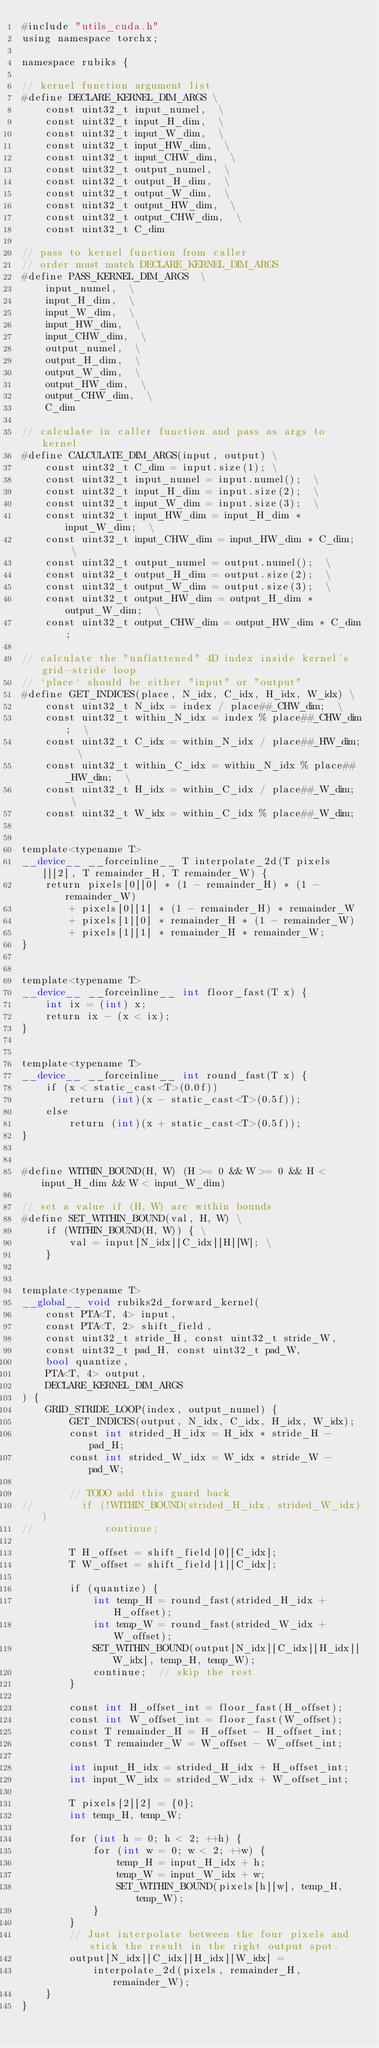<code> <loc_0><loc_0><loc_500><loc_500><_Cuda_>#include "utils_cuda.h"
using namespace torchx;

namespace rubiks {

// kernel function argument list
#define DECLARE_KERNEL_DIM_ARGS \
    const uint32_t input_numel,  \
    const uint32_t input_H_dim,  \
    const uint32_t input_W_dim,  \
    const uint32_t input_HW_dim,  \
    const uint32_t input_CHW_dim,  \
    const uint32_t output_numel,  \
    const uint32_t output_H_dim,  \
    const uint32_t output_W_dim,  \
    const uint32_t output_HW_dim,  \
    const uint32_t output_CHW_dim,  \
    const uint32_t C_dim
    
// pass to kernel function from caller
// order must match DECLARE_KERNEL_DIM_ARGS
#define PASS_KERNEL_DIM_ARGS  \
    input_numel,  \
    input_H_dim,  \
    input_W_dim,  \
    input_HW_dim,  \
    input_CHW_dim,  \
    output_numel,  \
    output_H_dim,  \
    output_W_dim,  \
    output_HW_dim,  \
    output_CHW_dim,  \
    C_dim

// calculate in caller function and pass as args to kernel
#define CALCULATE_DIM_ARGS(input, output) \
    const uint32_t C_dim = input.size(1); \
    const uint32_t input_numel = input.numel();  \
    const uint32_t input_H_dim = input.size(2);  \
    const uint32_t input_W_dim = input.size(3);  \
    const uint32_t input_HW_dim = input_H_dim * input_W_dim;  \
    const uint32_t input_CHW_dim = input_HW_dim * C_dim;  \
    const uint32_t output_numel = output.numel();  \
    const uint32_t output_H_dim = output.size(2);  \
    const uint32_t output_W_dim = output.size(3);  \
    const uint32_t output_HW_dim = output_H_dim * output_W_dim;  \
    const uint32_t output_CHW_dim = output_HW_dim * C_dim;

// calculate the "unflattened" 4D index inside kernel's grid-stride loop
// `place` should be either "input" or "output"
#define GET_INDICES(place, N_idx, C_idx, H_idx, W_idx) \
    const uint32_t N_idx = index / place##_CHW_dim;  \
    const uint32_t within_N_idx = index % place##_CHW_dim;  \
    const uint32_t C_idx = within_N_idx / place##_HW_dim;  \
    const uint32_t within_C_idx = within_N_idx % place##_HW_dim;  \
    const uint32_t H_idx = within_C_idx / place##_W_dim;  \
    const uint32_t W_idx = within_C_idx % place##_W_dim;


template<typename T>
__device__ __forceinline__ T interpolate_2d(T pixels[][2], T remainder_H, T remainder_W) {
    return pixels[0][0] * (1 - remainder_H) * (1 - remainder_W)
        + pixels[0][1] * (1 - remainder_H) * remainder_W
        + pixels[1][0] * remainder_H * (1 - remainder_W)
        + pixels[1][1] * remainder_H * remainder_W;
}


template<typename T>
__device__ __forceinline__ int floor_fast(T x) {
    int ix = (int) x;
    return ix - (x < ix);
}


template<typename T>
__device__ __forceinline__ int round_fast(T x) {
    if (x < static_cast<T>(0.0f))
        return (int)(x - static_cast<T>(0.5f));
    else
        return (int)(x + static_cast<T>(0.5f));
}


#define WITHIN_BOUND(H, W) (H >= 0 && W >= 0 && H < input_H_dim && W < input_W_dim)

// set a value if (H, W) are within bounds
#define SET_WITHIN_BOUND(val, H, W) \
    if (WITHIN_BOUND(H, W)) { \
        val = input[N_idx][C_idx][H][W]; \
    }


template<typename T>
__global__ void rubiks2d_forward_kernel(
    const PTA<T, 4> input,
    const PTA<T, 2> shift_field,
    const uint32_t stride_H, const uint32_t stride_W,
    const uint32_t pad_H, const uint32_t pad_W,
    bool quantize,
    PTA<T, 4> output,
    DECLARE_KERNEL_DIM_ARGS
) {
    GRID_STRIDE_LOOP(index, output_numel) {
        GET_INDICES(output, N_idx, C_idx, H_idx, W_idx);
        const int strided_H_idx = H_idx * stride_H - pad_H;
        const int strided_W_idx = W_idx * stride_W - pad_W;

        // TODO add this guard back
//        if (!WITHIN_BOUND(strided_H_idx, strided_W_idx))
//            continue;

        T H_offset = shift_field[0][C_idx];
        T W_offset = shift_field[1][C_idx];

        if (quantize) {
            int temp_H = round_fast(strided_H_idx + H_offset);
            int temp_W = round_fast(strided_W_idx + W_offset);
            SET_WITHIN_BOUND(output[N_idx][C_idx][H_idx][W_idx], temp_H, temp_W);
            continue;  // skip the rest
        }

        const int H_offset_int = floor_fast(H_offset);
        const int W_offset_int = floor_fast(W_offset);
        const T remainder_H = H_offset - H_offset_int;
        const T remainder_W = W_offset - W_offset_int;

        int input_H_idx = strided_H_idx + H_offset_int;
        int input_W_idx = strided_W_idx + W_offset_int;

        T pixels[2][2] = {0};
        int temp_H, temp_W;

        for (int h = 0; h < 2; ++h) {
            for (int w = 0; w < 2; ++w) {
                temp_H = input_H_idx + h;
                temp_W = input_W_idx + w;
                SET_WITHIN_BOUND(pixels[h][w], temp_H, temp_W);
            }
        }
        // Just interpolate between the four pixels and stick the result in the right output spot.
        output[N_idx][C_idx][H_idx][W_idx] =
            interpolate_2d(pixels, remainder_H, remainder_W);
    }
}
</code> 